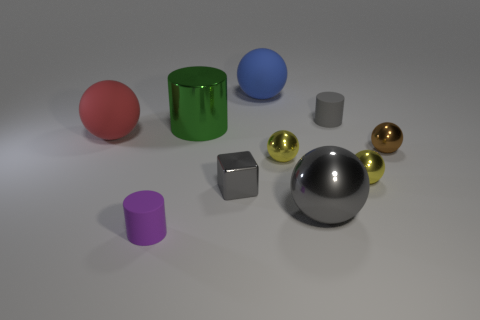The rubber thing that is the same color as the cube is what size?
Make the answer very short. Small. Are there any blue balls that have the same material as the purple cylinder?
Your answer should be very brief. Yes. Are there the same number of small yellow shiny balls on the left side of the green metallic object and big objects that are behind the small brown metal thing?
Provide a succinct answer. No. There is a cylinder that is behind the large metallic cylinder; what size is it?
Keep it short and to the point. Small. What material is the big object that is on the left side of the small rubber object on the left side of the large blue ball made of?
Offer a very short reply. Rubber. How many big gray metal balls are behind the large sphere that is behind the matte cylinder that is right of the small purple matte cylinder?
Your answer should be very brief. 0. Does the small cylinder to the left of the large blue sphere have the same material as the tiny brown sphere that is on the right side of the green metallic object?
Give a very brief answer. No. There is a small thing that is the same color as the small metallic cube; what is its material?
Make the answer very short. Rubber. What number of large yellow rubber objects are the same shape as the big green metallic thing?
Your answer should be very brief. 0. Are there more shiny blocks that are behind the large green metallic object than purple things?
Your answer should be very brief. No. 